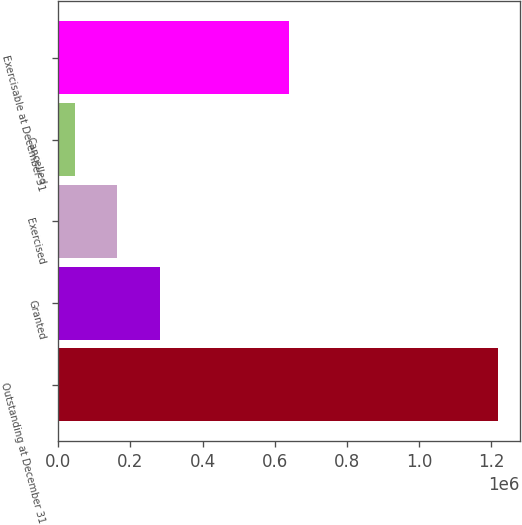Convert chart. <chart><loc_0><loc_0><loc_500><loc_500><bar_chart><fcel>Outstanding at December 31<fcel>Granted<fcel>Exercised<fcel>Cancelled<fcel>Exercisable at December 31<nl><fcel>1.21712e+06<fcel>280884<fcel>162594<fcel>45424<fcel>640725<nl></chart> 